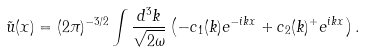Convert formula to latex. <formula><loc_0><loc_0><loc_500><loc_500>\tilde { u } ( x ) = ( 2 \pi ) ^ { - 3 / 2 } \int \frac { d ^ { 3 } k } { \sqrt { 2 \omega } } \left ( - c _ { 1 } ( { k } ) e ^ { - i k x } + c _ { 2 } ( { k } ) ^ { + } e ^ { i k x } \right ) .</formula> 